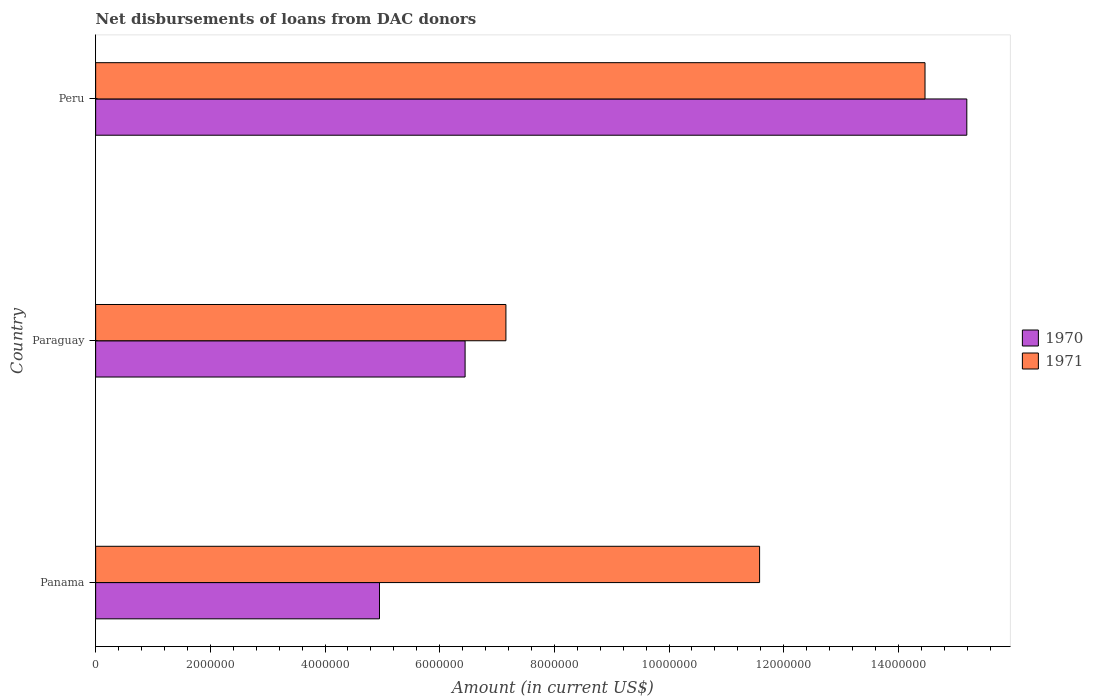How many different coloured bars are there?
Your answer should be very brief. 2. How many groups of bars are there?
Provide a succinct answer. 3. Are the number of bars per tick equal to the number of legend labels?
Provide a succinct answer. Yes. How many bars are there on the 2nd tick from the bottom?
Offer a very short reply. 2. What is the label of the 2nd group of bars from the top?
Give a very brief answer. Paraguay. In how many cases, is the number of bars for a given country not equal to the number of legend labels?
Ensure brevity in your answer.  0. What is the amount of loans disbursed in 1971 in Peru?
Keep it short and to the point. 1.45e+07. Across all countries, what is the maximum amount of loans disbursed in 1971?
Ensure brevity in your answer.  1.45e+07. Across all countries, what is the minimum amount of loans disbursed in 1971?
Your answer should be very brief. 7.16e+06. In which country was the amount of loans disbursed in 1971 maximum?
Ensure brevity in your answer.  Peru. In which country was the amount of loans disbursed in 1970 minimum?
Offer a terse response. Panama. What is the total amount of loans disbursed in 1970 in the graph?
Your answer should be compact. 2.66e+07. What is the difference between the amount of loans disbursed in 1971 in Paraguay and that in Peru?
Your answer should be very brief. -7.31e+06. What is the difference between the amount of loans disbursed in 1970 in Paraguay and the amount of loans disbursed in 1971 in Panama?
Keep it short and to the point. -5.14e+06. What is the average amount of loans disbursed in 1971 per country?
Your response must be concise. 1.11e+07. What is the difference between the amount of loans disbursed in 1970 and amount of loans disbursed in 1971 in Paraguay?
Your answer should be very brief. -7.12e+05. In how many countries, is the amount of loans disbursed in 1971 greater than 400000 US$?
Your answer should be very brief. 3. What is the ratio of the amount of loans disbursed in 1970 in Panama to that in Peru?
Your answer should be very brief. 0.33. What is the difference between the highest and the second highest amount of loans disbursed in 1971?
Offer a very short reply. 2.88e+06. What is the difference between the highest and the lowest amount of loans disbursed in 1971?
Offer a very short reply. 7.31e+06. What does the 1st bar from the top in Peru represents?
Provide a short and direct response. 1971. How many bars are there?
Keep it short and to the point. 6. Are all the bars in the graph horizontal?
Your answer should be compact. Yes. Are the values on the major ticks of X-axis written in scientific E-notation?
Your answer should be very brief. No. Does the graph contain any zero values?
Provide a succinct answer. No. How are the legend labels stacked?
Offer a very short reply. Vertical. What is the title of the graph?
Provide a short and direct response. Net disbursements of loans from DAC donors. Does "1999" appear as one of the legend labels in the graph?
Provide a short and direct response. No. What is the label or title of the X-axis?
Your answer should be compact. Amount (in current US$). What is the Amount (in current US$) of 1970 in Panama?
Ensure brevity in your answer.  4.95e+06. What is the Amount (in current US$) in 1971 in Panama?
Offer a very short reply. 1.16e+07. What is the Amount (in current US$) of 1970 in Paraguay?
Provide a succinct answer. 6.44e+06. What is the Amount (in current US$) in 1971 in Paraguay?
Ensure brevity in your answer.  7.16e+06. What is the Amount (in current US$) of 1970 in Peru?
Your response must be concise. 1.52e+07. What is the Amount (in current US$) of 1971 in Peru?
Provide a succinct answer. 1.45e+07. Across all countries, what is the maximum Amount (in current US$) in 1970?
Provide a succinct answer. 1.52e+07. Across all countries, what is the maximum Amount (in current US$) in 1971?
Keep it short and to the point. 1.45e+07. Across all countries, what is the minimum Amount (in current US$) of 1970?
Ensure brevity in your answer.  4.95e+06. Across all countries, what is the minimum Amount (in current US$) in 1971?
Keep it short and to the point. 7.16e+06. What is the total Amount (in current US$) of 1970 in the graph?
Provide a succinct answer. 2.66e+07. What is the total Amount (in current US$) in 1971 in the graph?
Provide a succinct answer. 3.32e+07. What is the difference between the Amount (in current US$) in 1970 in Panama and that in Paraguay?
Your response must be concise. -1.49e+06. What is the difference between the Amount (in current US$) of 1971 in Panama and that in Paraguay?
Offer a terse response. 4.42e+06. What is the difference between the Amount (in current US$) of 1970 in Panama and that in Peru?
Offer a terse response. -1.02e+07. What is the difference between the Amount (in current US$) of 1971 in Panama and that in Peru?
Offer a terse response. -2.88e+06. What is the difference between the Amount (in current US$) in 1970 in Paraguay and that in Peru?
Give a very brief answer. -8.75e+06. What is the difference between the Amount (in current US$) of 1971 in Paraguay and that in Peru?
Your response must be concise. -7.31e+06. What is the difference between the Amount (in current US$) in 1970 in Panama and the Amount (in current US$) in 1971 in Paraguay?
Make the answer very short. -2.20e+06. What is the difference between the Amount (in current US$) of 1970 in Panama and the Amount (in current US$) of 1971 in Peru?
Give a very brief answer. -9.51e+06. What is the difference between the Amount (in current US$) in 1970 in Paraguay and the Amount (in current US$) in 1971 in Peru?
Keep it short and to the point. -8.02e+06. What is the average Amount (in current US$) in 1970 per country?
Provide a succinct answer. 8.86e+06. What is the average Amount (in current US$) of 1971 per country?
Your answer should be very brief. 1.11e+07. What is the difference between the Amount (in current US$) of 1970 and Amount (in current US$) of 1971 in Panama?
Provide a short and direct response. -6.63e+06. What is the difference between the Amount (in current US$) in 1970 and Amount (in current US$) in 1971 in Paraguay?
Your response must be concise. -7.12e+05. What is the difference between the Amount (in current US$) in 1970 and Amount (in current US$) in 1971 in Peru?
Your answer should be compact. 7.29e+05. What is the ratio of the Amount (in current US$) of 1970 in Panama to that in Paraguay?
Offer a very short reply. 0.77. What is the ratio of the Amount (in current US$) in 1971 in Panama to that in Paraguay?
Ensure brevity in your answer.  1.62. What is the ratio of the Amount (in current US$) in 1970 in Panama to that in Peru?
Your response must be concise. 0.33. What is the ratio of the Amount (in current US$) of 1971 in Panama to that in Peru?
Provide a short and direct response. 0.8. What is the ratio of the Amount (in current US$) in 1970 in Paraguay to that in Peru?
Offer a terse response. 0.42. What is the ratio of the Amount (in current US$) in 1971 in Paraguay to that in Peru?
Provide a succinct answer. 0.49. What is the difference between the highest and the second highest Amount (in current US$) in 1970?
Give a very brief answer. 8.75e+06. What is the difference between the highest and the second highest Amount (in current US$) of 1971?
Make the answer very short. 2.88e+06. What is the difference between the highest and the lowest Amount (in current US$) in 1970?
Make the answer very short. 1.02e+07. What is the difference between the highest and the lowest Amount (in current US$) in 1971?
Offer a very short reply. 7.31e+06. 